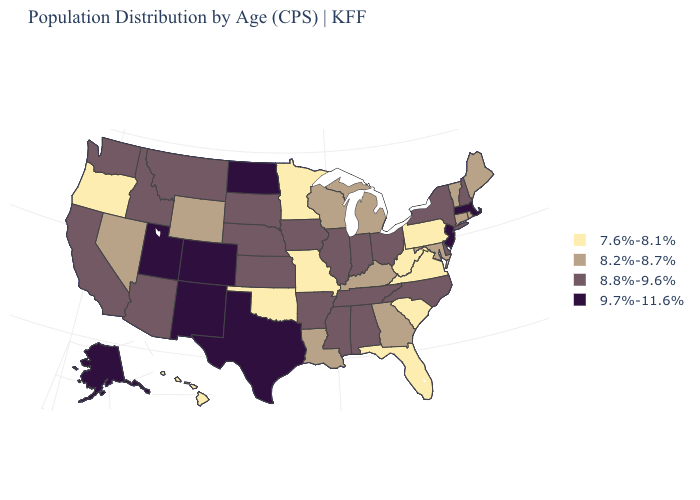Which states have the lowest value in the USA?
Answer briefly. Florida, Hawaii, Minnesota, Missouri, Oklahoma, Oregon, Pennsylvania, South Carolina, Virginia, West Virginia. What is the value of Hawaii?
Quick response, please. 7.6%-8.1%. Name the states that have a value in the range 8.2%-8.7%?
Answer briefly. Connecticut, Georgia, Kentucky, Louisiana, Maine, Maryland, Michigan, Nevada, Rhode Island, Vermont, Wisconsin, Wyoming. Name the states that have a value in the range 9.7%-11.6%?
Write a very short answer. Alaska, Colorado, Massachusetts, New Jersey, New Mexico, North Dakota, Texas, Utah. Is the legend a continuous bar?
Keep it brief. No. What is the value of Louisiana?
Answer briefly. 8.2%-8.7%. Name the states that have a value in the range 8.2%-8.7%?
Be succinct. Connecticut, Georgia, Kentucky, Louisiana, Maine, Maryland, Michigan, Nevada, Rhode Island, Vermont, Wisconsin, Wyoming. Does the first symbol in the legend represent the smallest category?
Be succinct. Yes. What is the highest value in states that border Iowa?
Answer briefly. 8.8%-9.6%. Among the states that border Delaware , does Pennsylvania have the lowest value?
Write a very short answer. Yes. Which states have the lowest value in the Northeast?
Keep it brief. Pennsylvania. Name the states that have a value in the range 7.6%-8.1%?
Write a very short answer. Florida, Hawaii, Minnesota, Missouri, Oklahoma, Oregon, Pennsylvania, South Carolina, Virginia, West Virginia. What is the value of Utah?
Write a very short answer. 9.7%-11.6%. What is the value of Arkansas?
Write a very short answer. 8.8%-9.6%. Name the states that have a value in the range 7.6%-8.1%?
Quick response, please. Florida, Hawaii, Minnesota, Missouri, Oklahoma, Oregon, Pennsylvania, South Carolina, Virginia, West Virginia. 